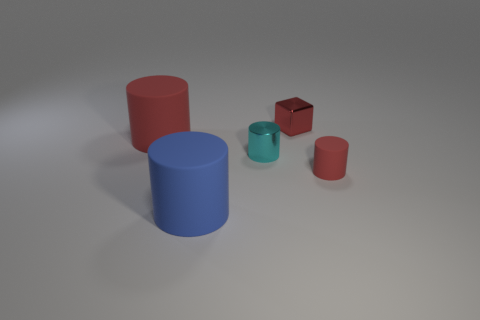Subtract all blue matte cylinders. How many cylinders are left? 3 Add 4 large red matte cylinders. How many objects exist? 9 Subtract all blue cylinders. How many cylinders are left? 3 Subtract all yellow balls. How many red cylinders are left? 2 Subtract all blocks. How many objects are left? 4 Subtract all blue cylinders. Subtract all purple cubes. How many cylinders are left? 3 Subtract all small red objects. Subtract all tiny green objects. How many objects are left? 3 Add 4 red matte cylinders. How many red matte cylinders are left? 6 Add 2 small red things. How many small red things exist? 4 Subtract 0 purple cubes. How many objects are left? 5 